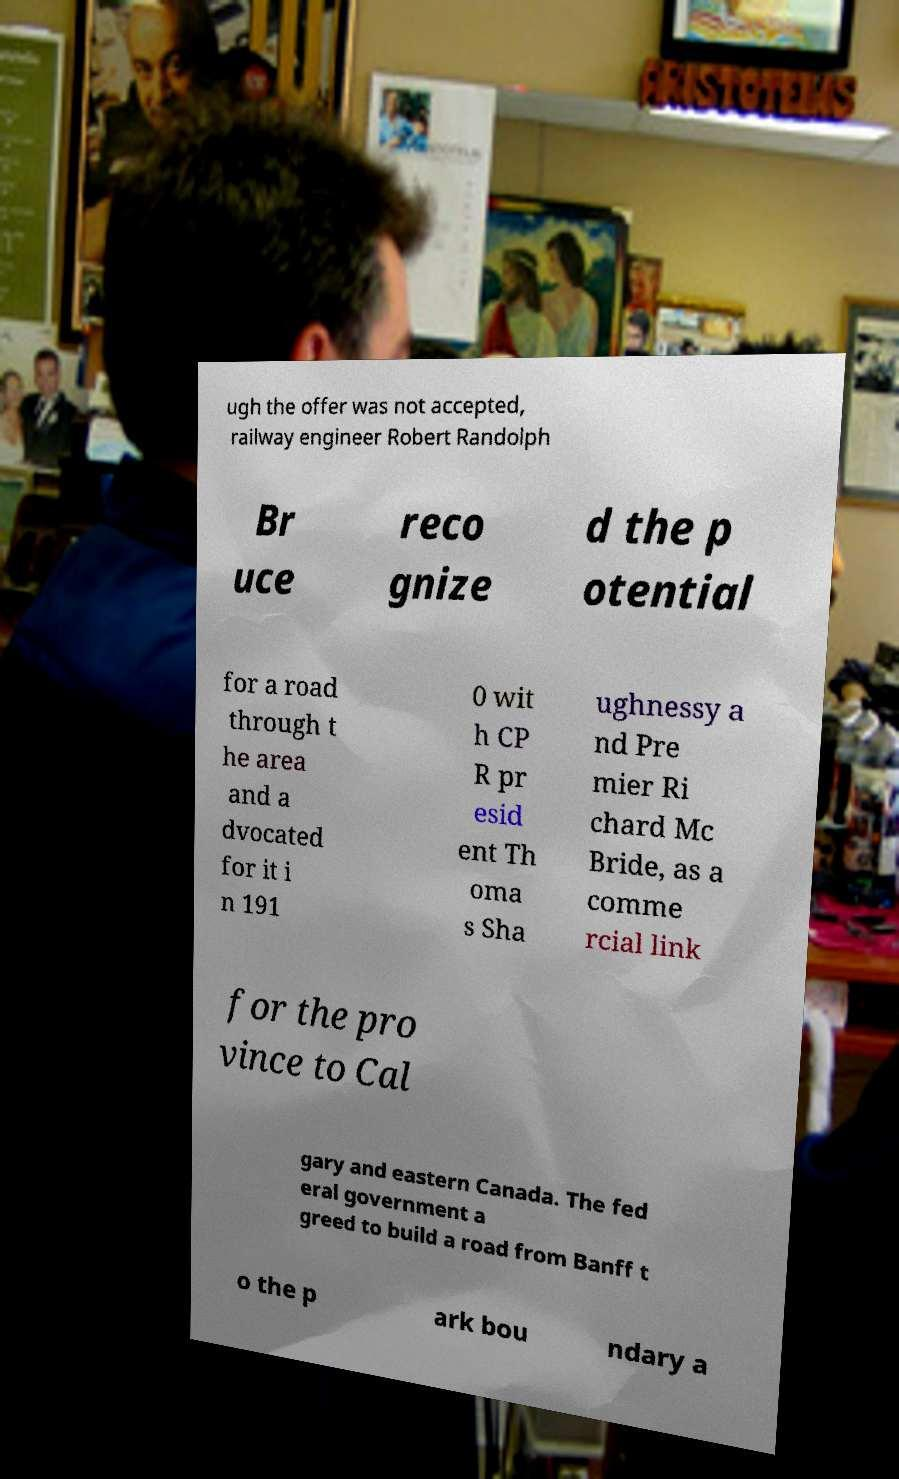Could you assist in decoding the text presented in this image and type it out clearly? ugh the offer was not accepted, railway engineer Robert Randolph Br uce reco gnize d the p otential for a road through t he area and a dvocated for it i n 191 0 wit h CP R pr esid ent Th oma s Sha ughnessy a nd Pre mier Ri chard Mc Bride, as a comme rcial link for the pro vince to Cal gary and eastern Canada. The fed eral government a greed to build a road from Banff t o the p ark bou ndary a 